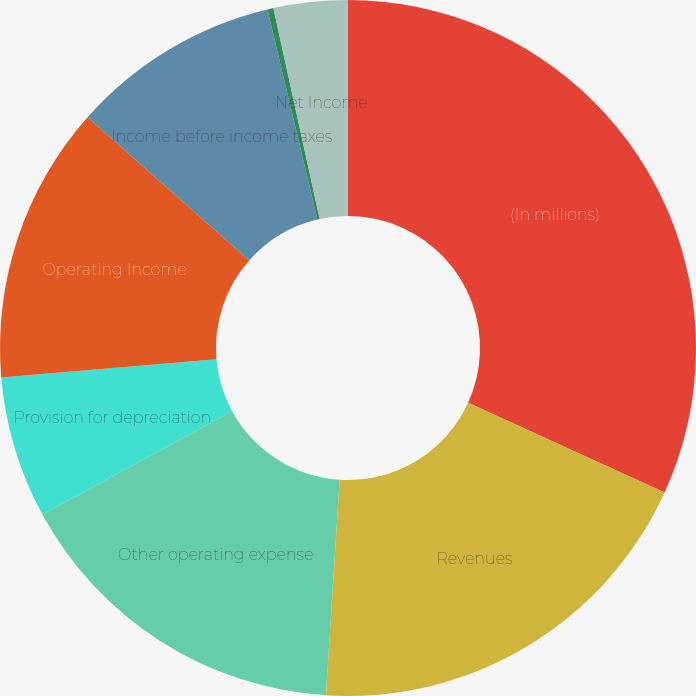Convert chart. <chart><loc_0><loc_0><loc_500><loc_500><pie_chart><fcel>(In millions)<fcel>Revenues<fcel>Other operating expense<fcel>Provision for depreciation<fcel>Operating Income<fcel>Income before income taxes<fcel>Income taxes<fcel>Net Income<nl><fcel>31.81%<fcel>19.2%<fcel>16.05%<fcel>6.59%<fcel>12.89%<fcel>9.74%<fcel>0.28%<fcel>3.44%<nl></chart> 